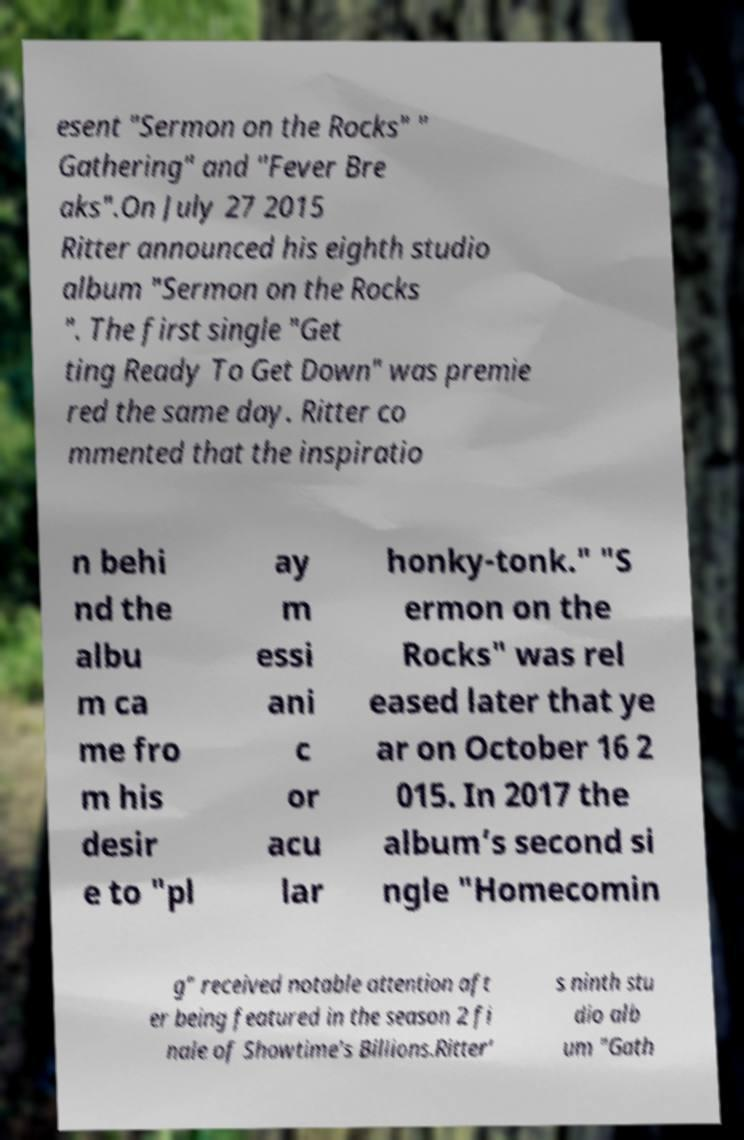Can you read and provide the text displayed in the image?This photo seems to have some interesting text. Can you extract and type it out for me? esent "Sermon on the Rocks" " Gathering" and "Fever Bre aks".On July 27 2015 Ritter announced his eighth studio album "Sermon on the Rocks ". The first single "Get ting Ready To Get Down" was premie red the same day. Ritter co mmented that the inspiratio n behi nd the albu m ca me fro m his desir e to "pl ay m essi ani c or acu lar honky-tonk." "S ermon on the Rocks" was rel eased later that ye ar on October 16 2 015. In 2017 the album’s second si ngle "Homecomin g" received notable attention aft er being featured in the season 2 fi nale of Showtime’s Billions.Ritter’ s ninth stu dio alb um "Gath 